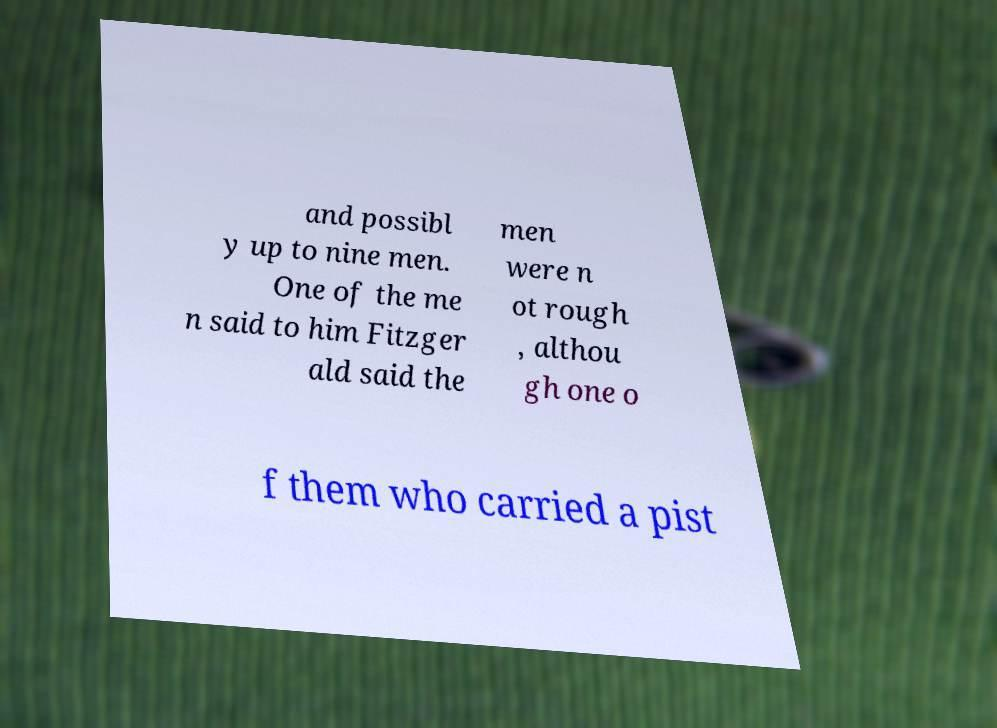I need the written content from this picture converted into text. Can you do that? and possibl y up to nine men. One of the me n said to him Fitzger ald said the men were n ot rough , althou gh one o f them who carried a pist 